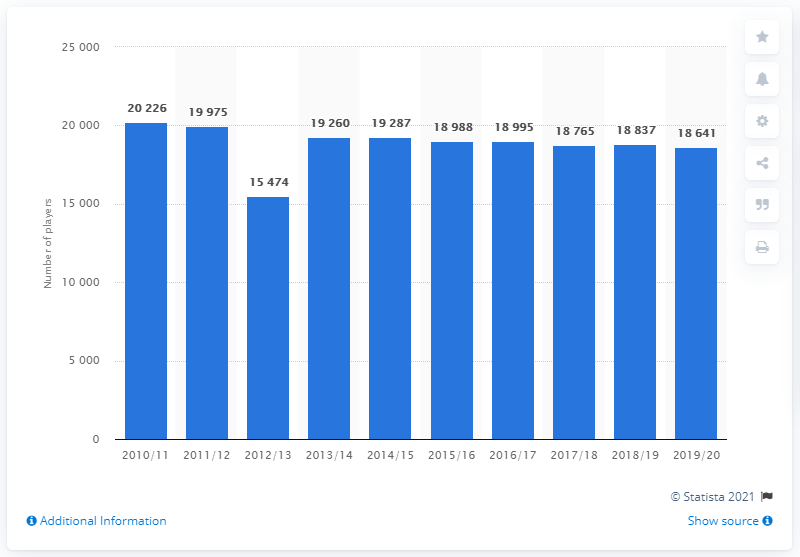Specify some key components in this picture. In the 2019/2020 ice hockey season, a total of 18,641 registered players in Japan were recorded. 